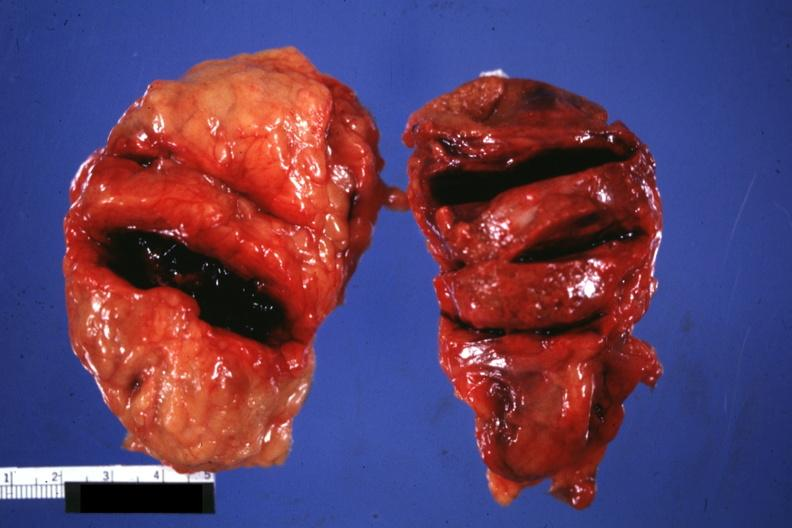what is present?
Answer the question using a single word or phrase. Endocrine 